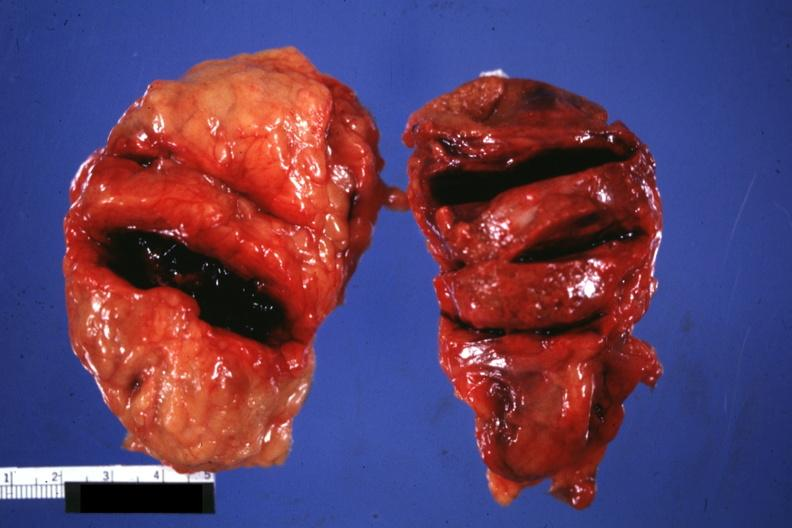what is present?
Answer the question using a single word or phrase. Endocrine 